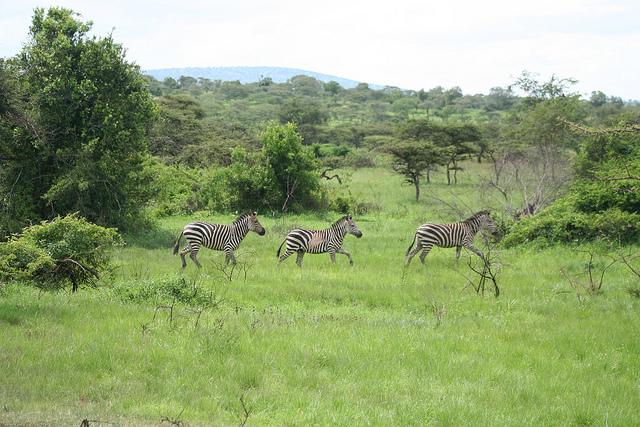What type of animals in the field?
Concise answer only. Zebra. Where is this at?
Keep it brief. Africa. How many zebras are there?
Short answer required. 3. How many zebras do you see?
Write a very short answer. 3. Do the animals seem afraid of the photographer?
Answer briefly. No. Do the zebras appear lost?
Keep it brief. No. 